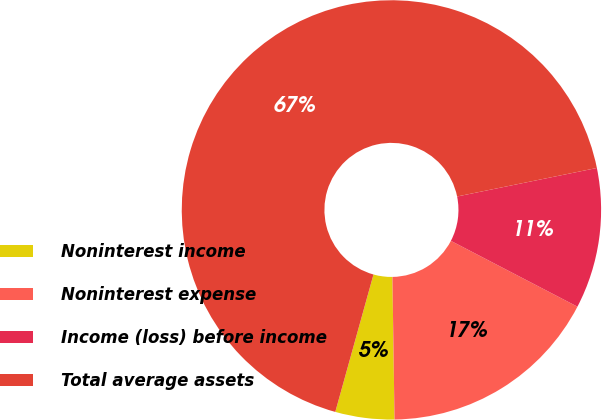<chart> <loc_0><loc_0><loc_500><loc_500><pie_chart><fcel>Noninterest income<fcel>Noninterest expense<fcel>Income (loss) before income<fcel>Total average assets<nl><fcel>4.55%<fcel>17.13%<fcel>10.84%<fcel>67.48%<nl></chart> 